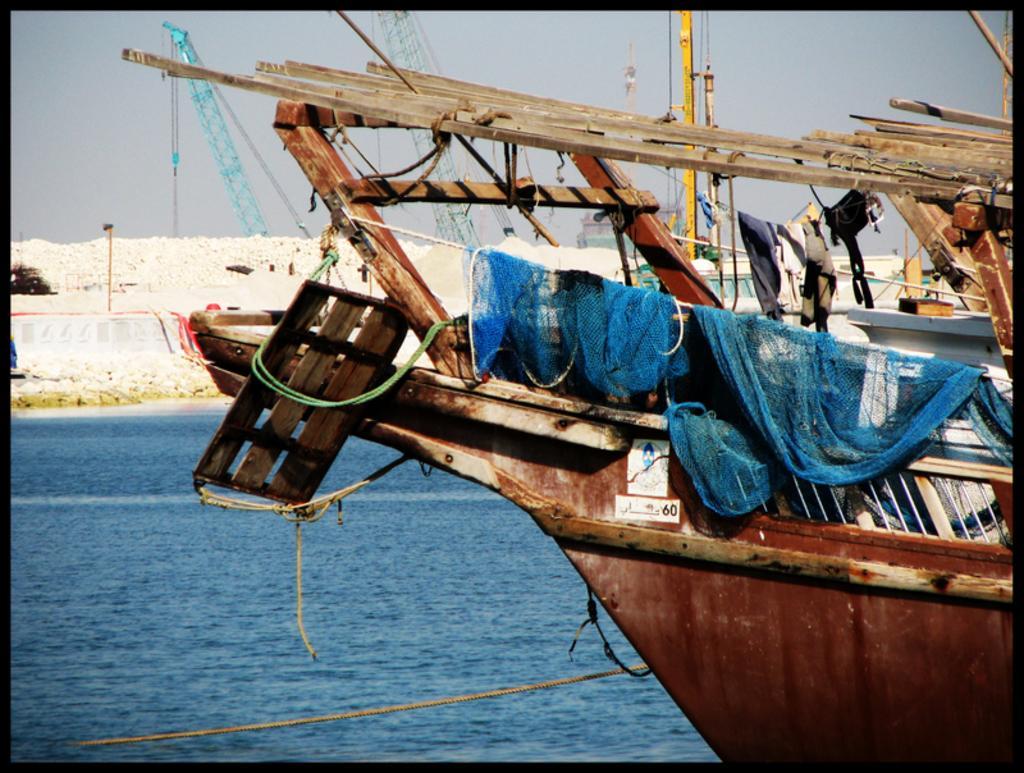Describe this image in one or two sentences. In this image we can see the ships on the water, there are some stones and cranes, in the background, we can see the sky. 